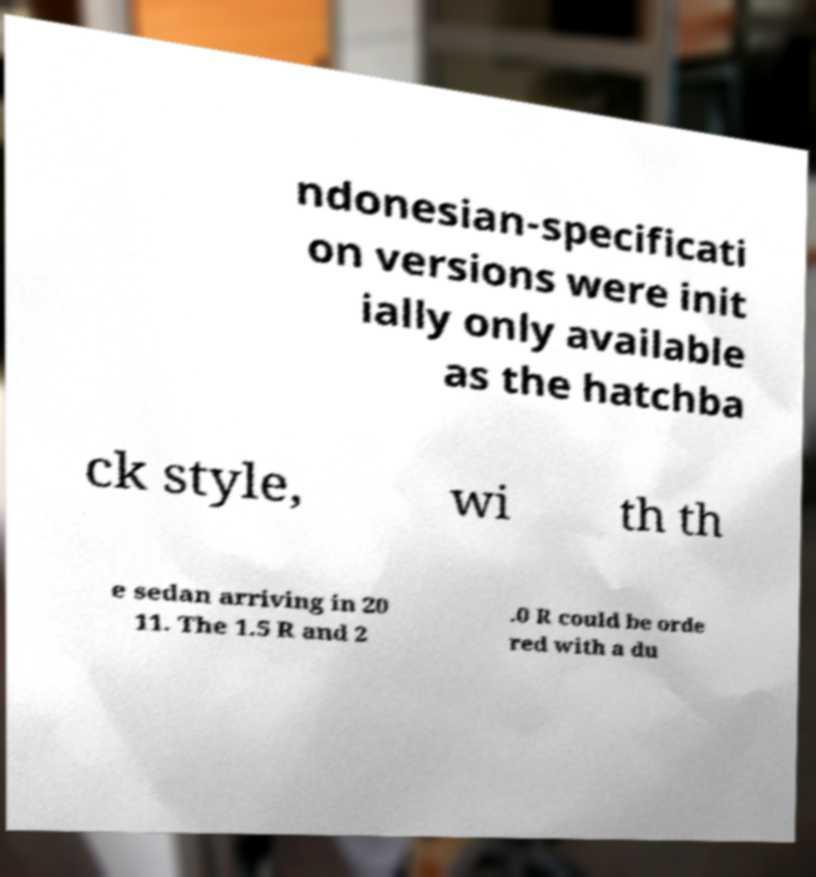Can you read and provide the text displayed in the image?This photo seems to have some interesting text. Can you extract and type it out for me? ndonesian-specificati on versions were init ially only available as the hatchba ck style, wi th th e sedan arriving in 20 11. The 1.5 R and 2 .0 R could be orde red with a du 